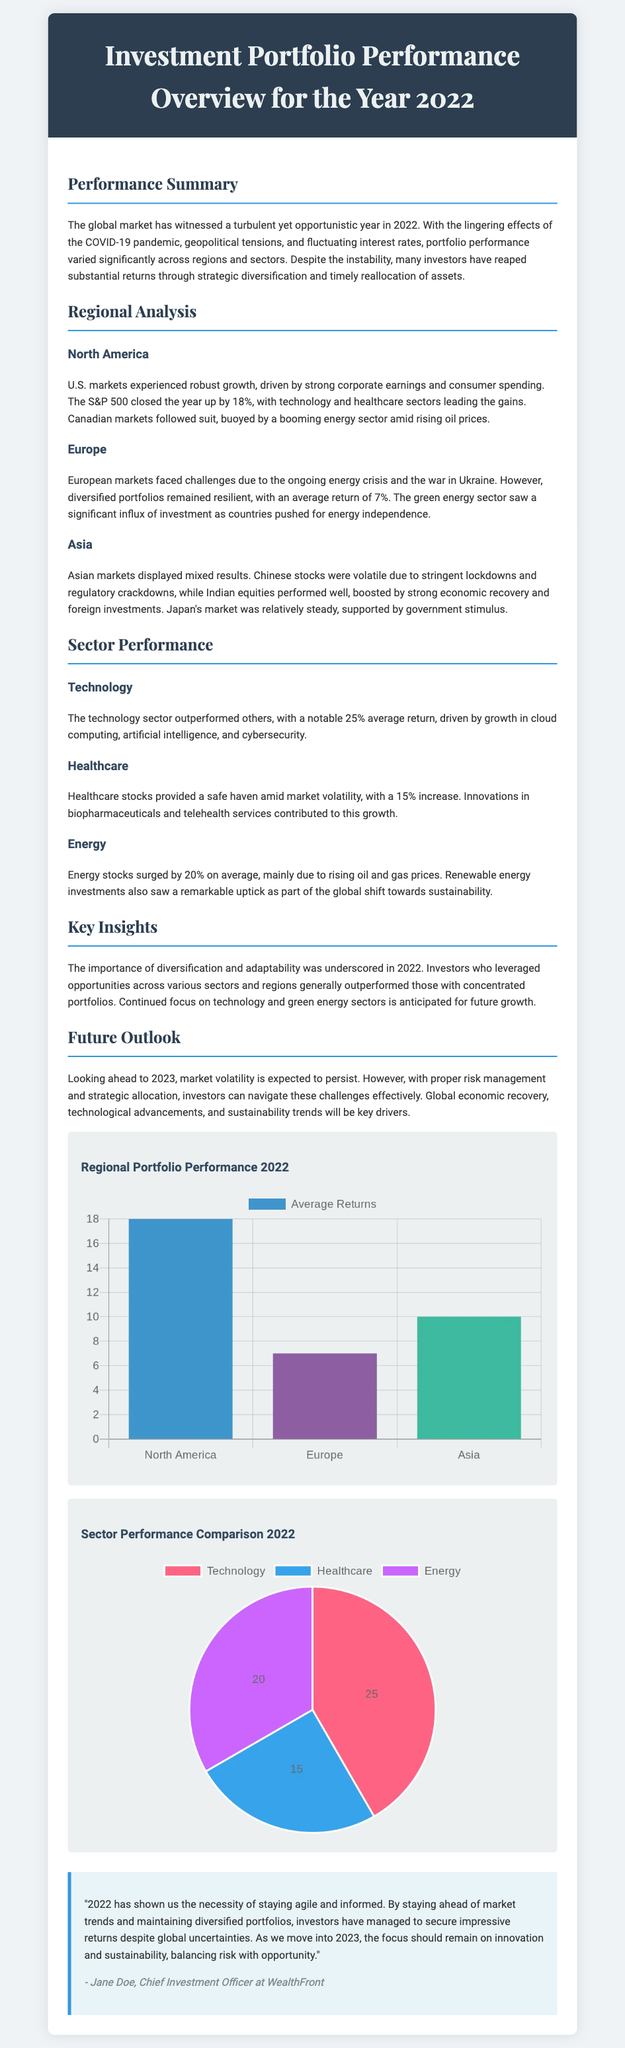What was the average return for North America in 2022? The average return for North America in 2022 is stated to be 18%.
Answer: 18% What sector provided a safe haven amid market volatility? The document mentions that healthcare stocks provided a safe haven amid market volatility.
Answer: Healthcare What was the average return for the energy sector? The average return for the energy sector is noted as 20%.
Answer: 20% Which market faced challenges due to the energy crisis and the war in Ukraine? The text specifies that European markets faced challenges due to the energy crisis and the war in Ukraine.
Answer: Europe Who is the author of the commentary at the end of the document? The commentary is attributed to Jane Doe, Chief Investment Officer at WealthFront.
Answer: Jane Doe What was the average return for Asian markets in 2022? The document states that Asian markets displayed mixed results, with an average return of 10%.
Answer: 10% What is the predicted focus for investors moving into 2023? The document indicates that the focus should remain on innovation and sustainability.
Answer: Innovation and sustainability What was the average return for the technology sector? The technology sector had a notable average return of 25%.
Answer: 25% What type of chart is used for regional portfolio performance? The chart for regional portfolio performance is a bar chart.
Answer: Bar chart 